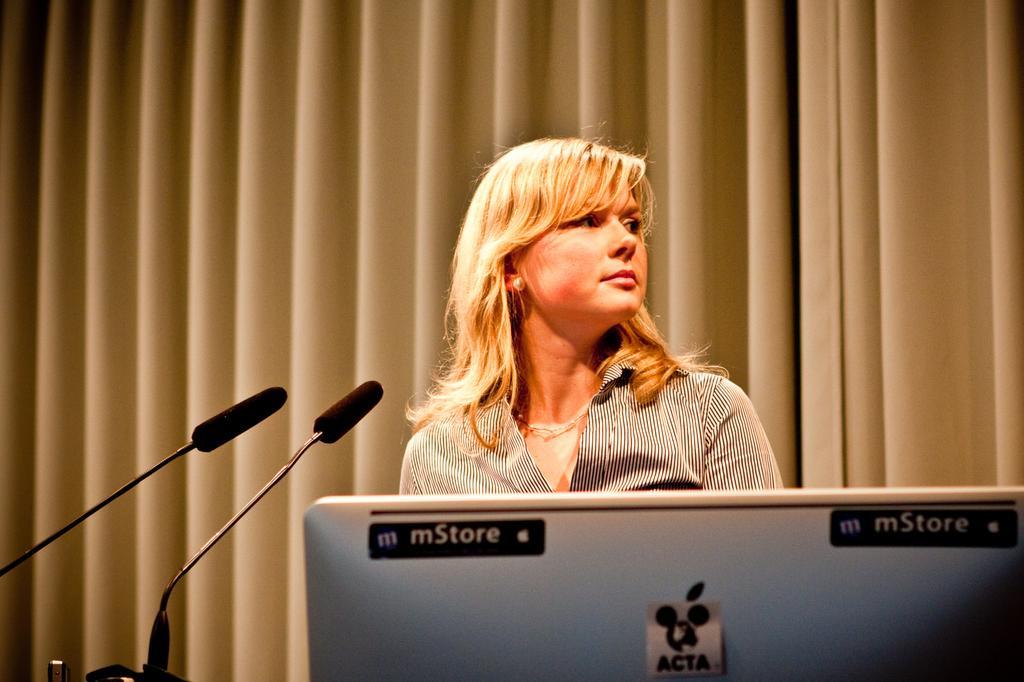Please provide a concise description of this image. In this image we can see a woman and mike's. On the backside we can see a curtain. 